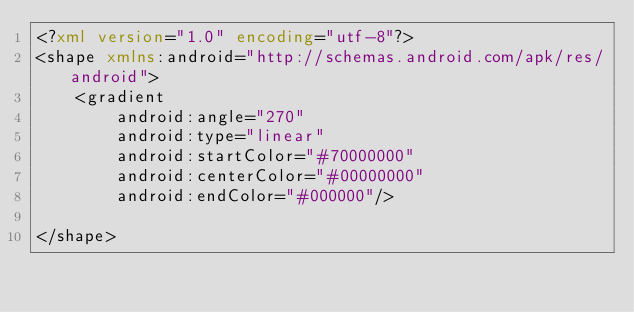Convert code to text. <code><loc_0><loc_0><loc_500><loc_500><_XML_><?xml version="1.0" encoding="utf-8"?>
<shape xmlns:android="http://schemas.android.com/apk/res/android">
    <gradient
        android:angle="270"
        android:type="linear"
        android:startColor="#70000000"
        android:centerColor="#00000000"
        android:endColor="#000000"/>

</shape></code> 